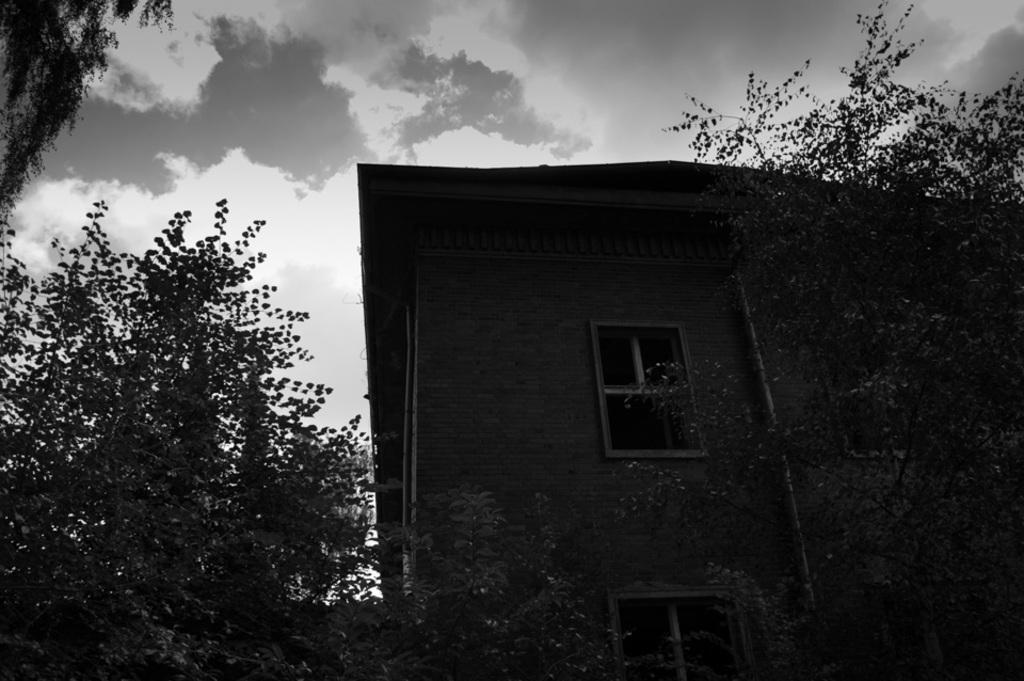What is the color scheme of the image? The image is black and white. What is the main subject in the middle of the image? There is a building in the middle of the image. What can be seen at the top of the image? The sky is visible at the top of the image. What type of vegetation surrounds the building? There are trees around the building. Can you hear the bell ringing in the image? There is no bell present in the image, so it cannot be heard. What type of sand can be seen on the ground in the image? There is no sand visible in the image; it features a building, trees, and a sky. 